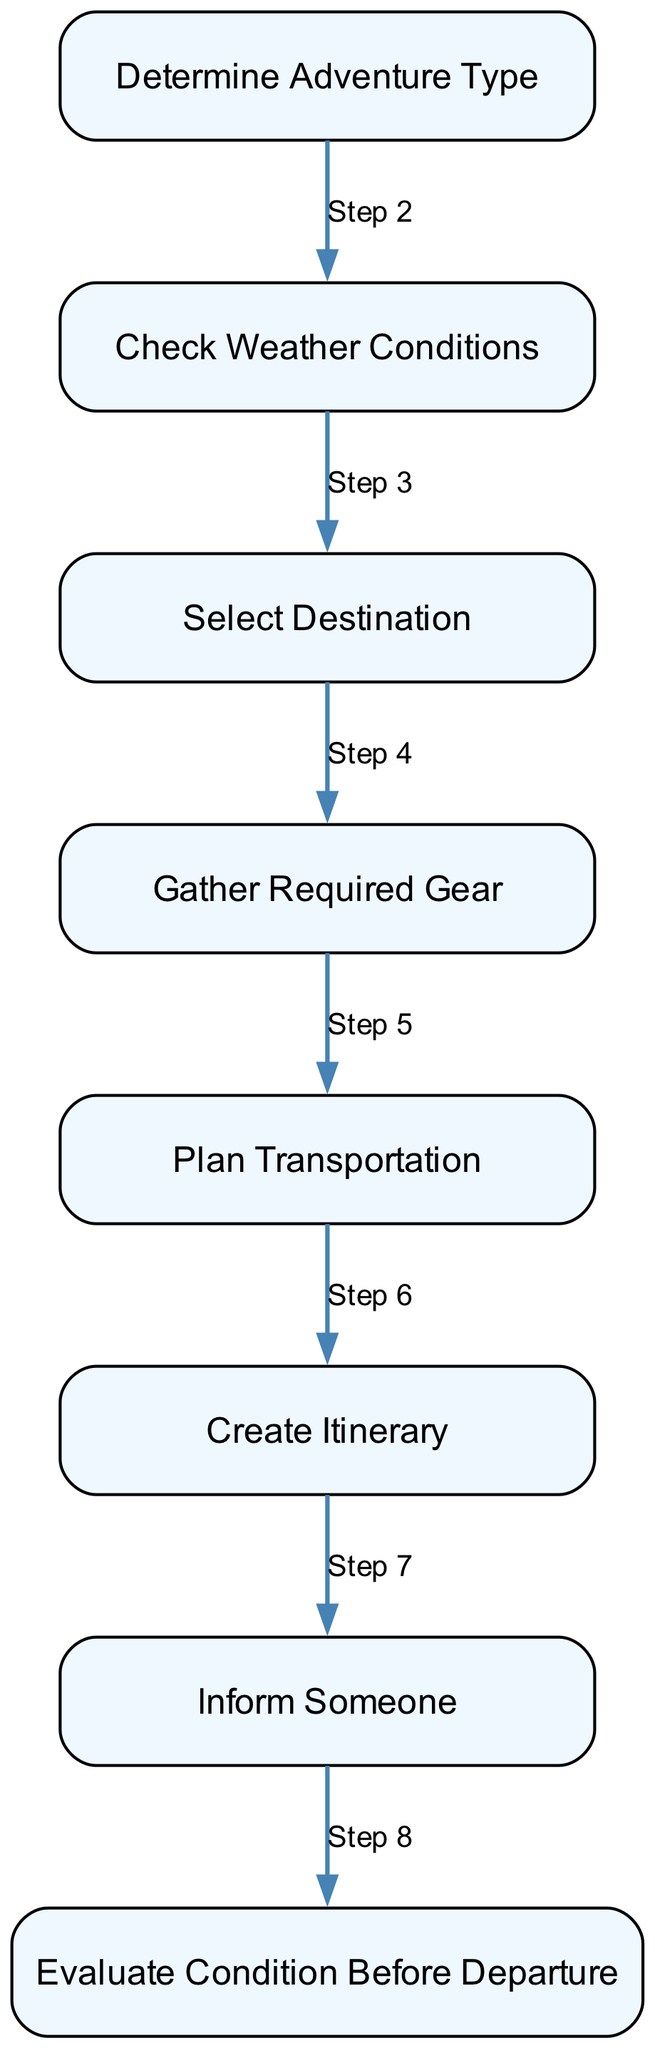What is the first step in the outdoor adventure planning process? The first step is to "Determine Adventure Type," which involves deciding the specific outdoor activity based on personal preferences.
Answer: Determine Adventure Type How many steps are there in the diagram? The diagram has a total of eight distinct steps, each representing a stage in the outdoor adventure planning process.
Answer: Eight What follows "Check Weather Conditions"? "Select Destination" follows "Check Weather Conditions," indicating that after assessing the weather, the next action is to choose a specific location for the adventure.
Answer: Select Destination Which step involves notifying others about the adventure? The step titled "Inform Someone" specifically involves notifying a friend or family member about the adventure plan for safety purposes.
Answer: Inform Someone What do you do after gathering required gear? After gathering required gear, the next step is to "Plan Transportation," which involves arranging how to reach the selected destination.
Answer: Plan Transportation What happens if weather conditions are unfavorable at the time of departure? "Evaluate Condition Before Departure" is the step where you reassess weather and travel conditions right before leaving to ensure everything is safe for the adventure.
Answer: Evaluate Condition Before Departure How does "Create Itinerary" relate to "Determine Adventure Type"? "Create Itinerary" is dependent on the results of "Determine Adventure Type," as the timeline will be drafted based on the specific outdoor activity chosen initially.
Answer: Itinerary relates to Adventure Type What is a critical action before finalizing the adventure plan? A critical action is "Check Weather Conditions," where one must ensure the weather is favorable to avoid disruptions caused by storms.
Answer: Check Weather Conditions 